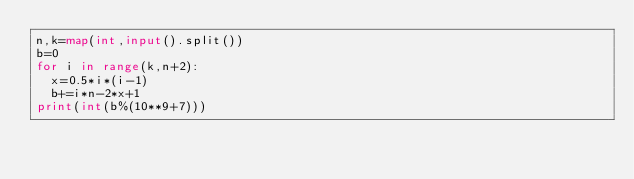<code> <loc_0><loc_0><loc_500><loc_500><_Python_>n,k=map(int,input().split())
b=0
for i in range(k,n+2):
  x=0.5*i*(i-1)
  b+=i*n-2*x+1
print(int(b%(10**9+7)))</code> 